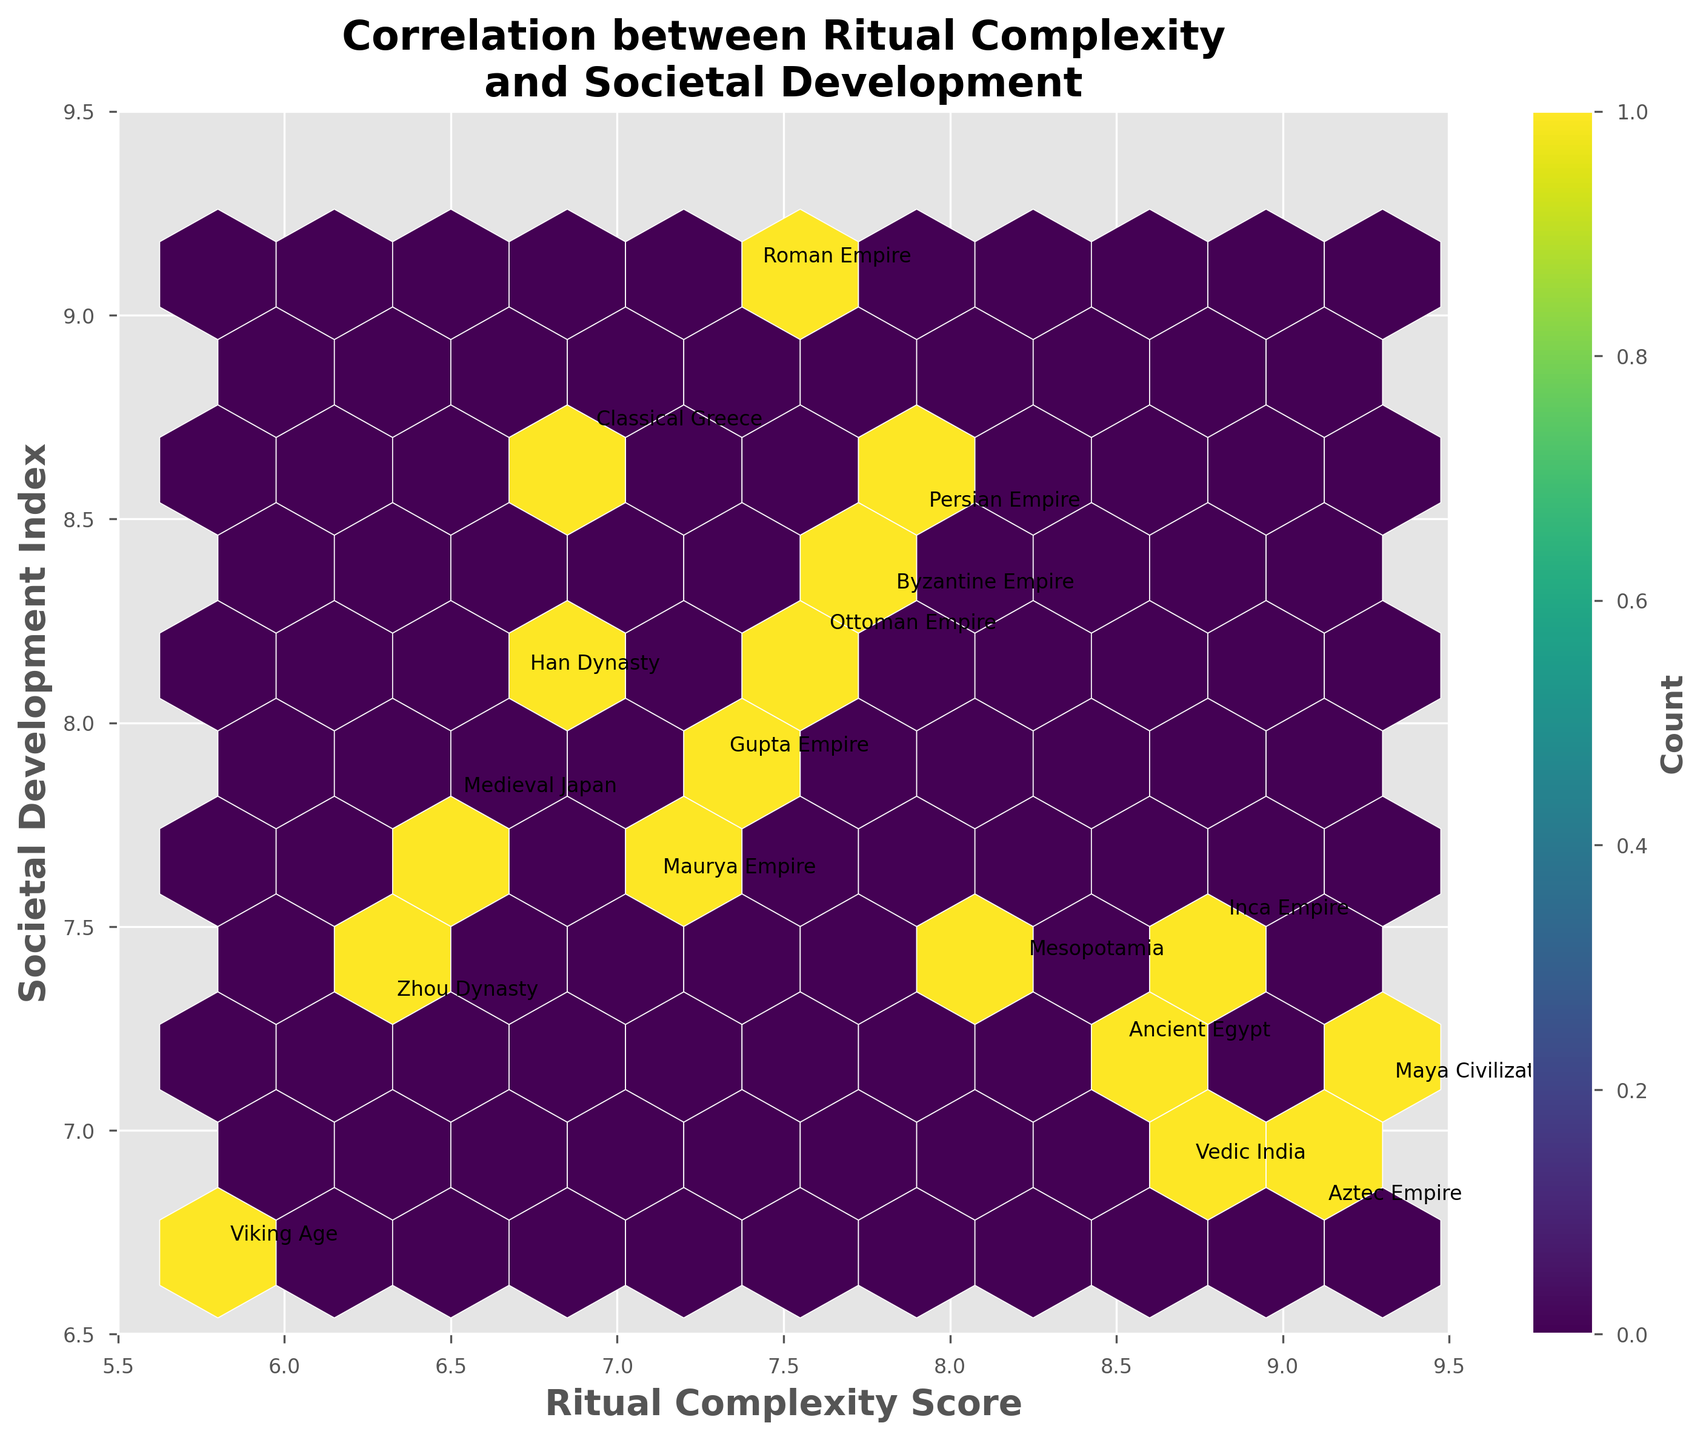what is the title of the figure? The title is the string of text at the top of the figure, displaying the main topic or focus of the plot. By looking at the top section, you can read the title.
Answer: Correlation between Ritual Complexity and Societal Development What are the axis labels? The axis labels are the texts adjacent to the x-axis and y-axis, describing what metrics are being plotted. Look at the horizontal and vertical texts to identify them.
Answer: Ritual Complexity Score, Societal Development Index What range is covered by the x-axis? Notice the numerical values displayed alongside the x-axis. The first and last values indicate the range. In this case, the x-axis range begins at 5.5 and ends at 9.5.
Answer: 5.5 to 9.5 Which civilization has the lowest Ritual Complexity Score? Locate the data point with the lowest x-axis value; it should have an accompanying annotation reflecting the corresponding civilization. The depicted lowest value is 5.8, and it's labeled as Viking Age.
Answer: Viking Age Which civilization has the highest Societal Development Index? Identify the data point with the highest y-axis value; the annotation near this point will correspond to the civilization. The highest y-value is 9.1, labeled as Roman Empire.
Answer: Roman Empire Which civilization appears to have the highest combined score of Ritual Complexity and Societal Development? Combined scores are calculated by summing the Ritual Complexity Score and Societal Development Index. Visually, locate the highest point with respect to both x and y coordinates. Annotations help identify this point, which is the Roman Empire with values 7.4 and 9.1.
Answer: Roman Empire How is the density of data points indicated in the plot? Density of data points in a hexbin plot is typically shown using color intensity. The hexagons with more data points are darker. This specific plot uses a viridis colormap to represent densities.
Answer: Color intensity What does the color bar on the right side represent? The color bar adjacent to the figure shows the correlation between the hexagons' colors and the number of data points found within them. The label 'Count' indicates this relation.
Answer: Count Which areas have the highest data point density in the plot? The areas with the darkest hexagons have the most data points. By inspecting the figure, these darker regions help to locate where the highest densities are found.
Answer: Central area, around (7.3, 7.9) 